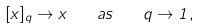Convert formula to latex. <formula><loc_0><loc_0><loc_500><loc_500>[ x ] _ { q } \to x \quad a s \quad q \to 1 ,</formula> 